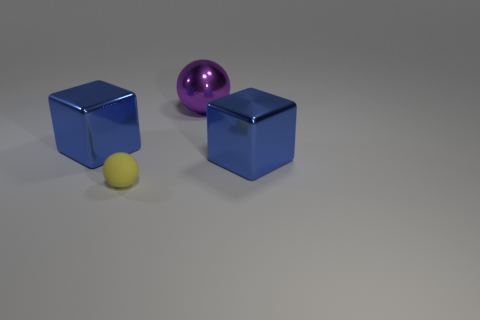Does the large purple shiny thing have the same shape as the big blue metallic thing to the left of the large purple thing?
Give a very brief answer. No. There is a purple sphere; are there any large purple balls in front of it?
Your answer should be compact. No. How many cylinders are big things or matte objects?
Give a very brief answer. 0. Is the large purple metallic object the same shape as the yellow matte thing?
Provide a succinct answer. Yes. There is a thing on the left side of the tiny yellow sphere; how big is it?
Give a very brief answer. Large. Is there a shiny block of the same color as the tiny matte thing?
Provide a succinct answer. No. There is a blue thing that is left of the purple sphere; is it the same size as the small matte ball?
Keep it short and to the point. No. The large ball is what color?
Ensure brevity in your answer.  Purple. The big metallic thing that is in front of the metallic cube to the left of the big metal sphere is what color?
Provide a short and direct response. Blue. Are there any green balls made of the same material as the yellow sphere?
Offer a very short reply. No. 